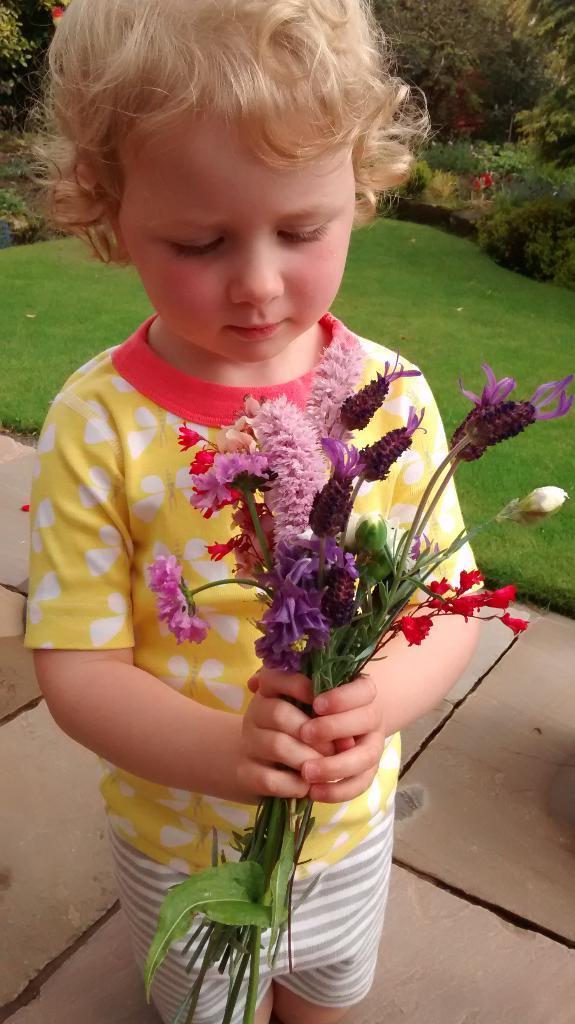Could you give a brief overview of what you see in this image? In this picture we can a kid holding a purple flower bouquet with green leaves & standing on a path surrounded by grass and trees. 